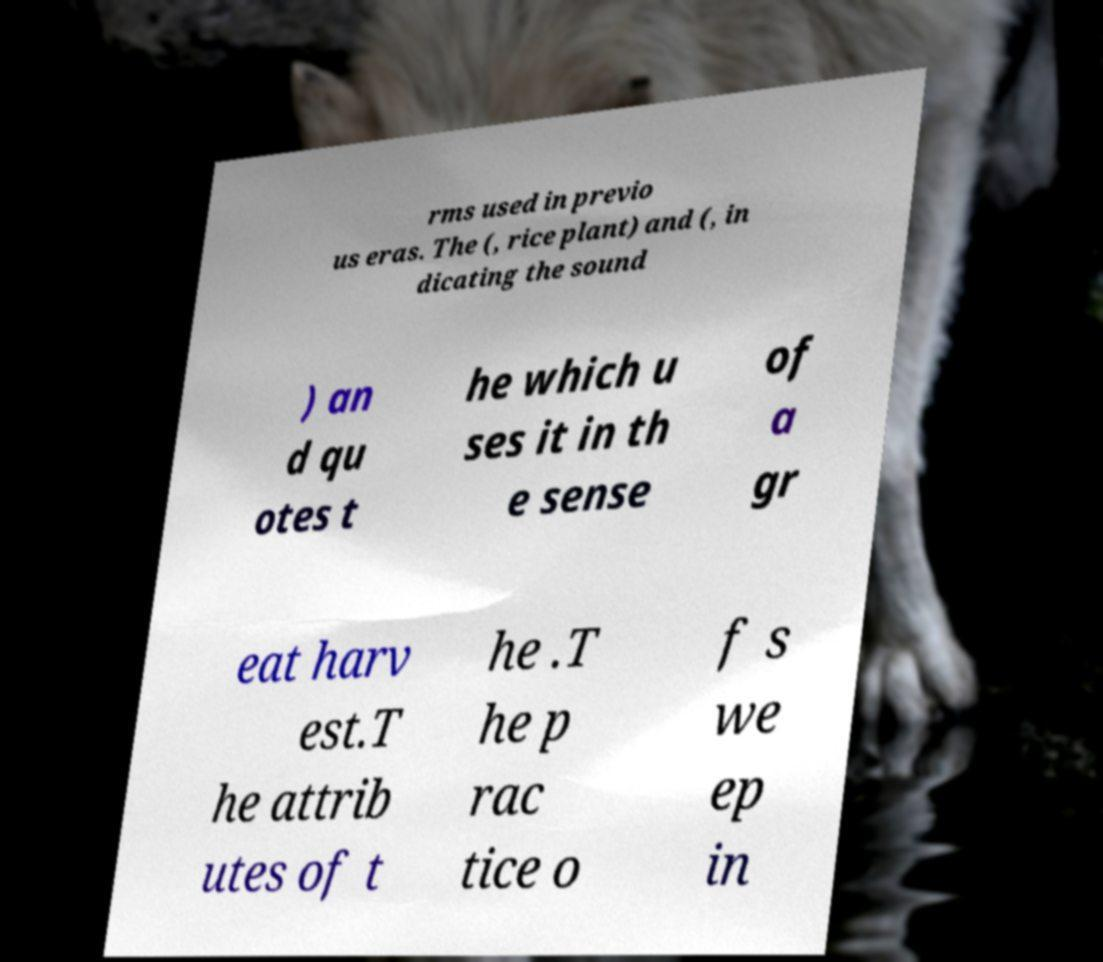Could you extract and type out the text from this image? rms used in previo us eras. The (, rice plant) and (, in dicating the sound ) an d qu otes t he which u ses it in th e sense of a gr eat harv est.T he attrib utes of t he .T he p rac tice o f s we ep in 